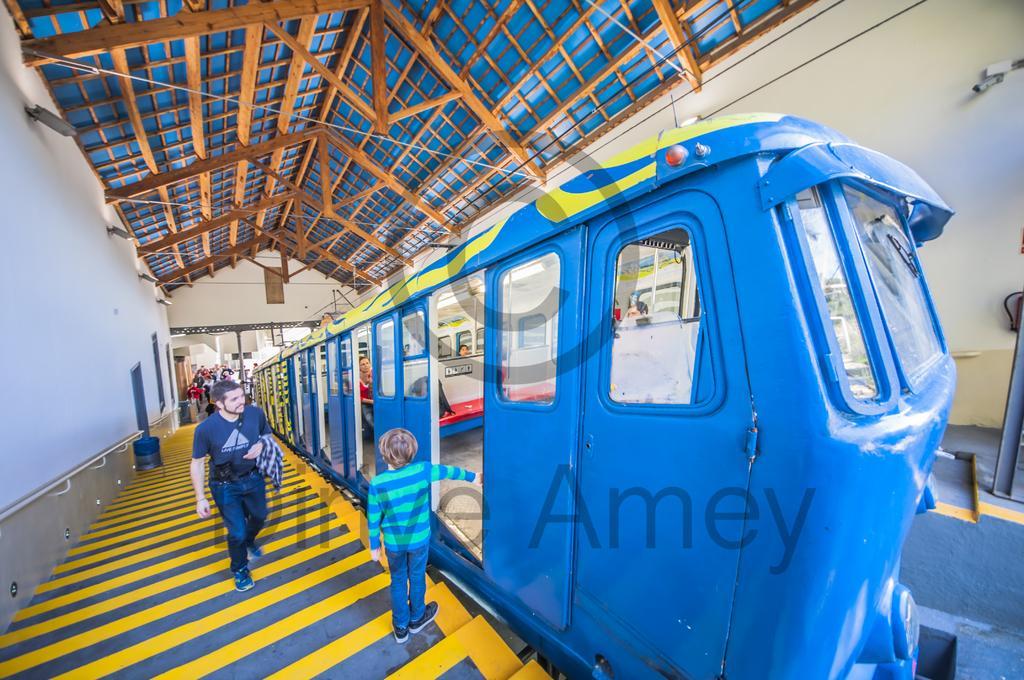Describe this image in one or two sentences. There is a blue color train in the subway and a kid is putting his hand into the door of the train and a person is walking towards the door,behind the person there are a lot of people and the roof of the subway is in blue color and under the roof there are many iron rods. 